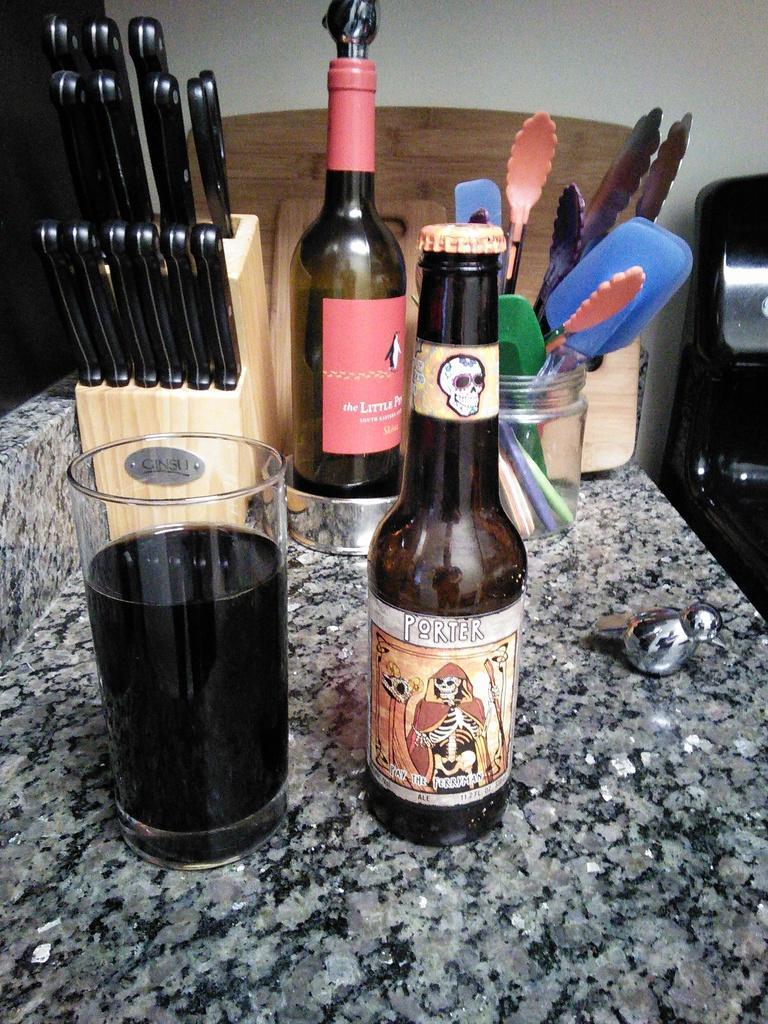Please provide a concise description of this image. There is a table which consists of bottles,a group of knives,spoons and a glass of drink on it. 